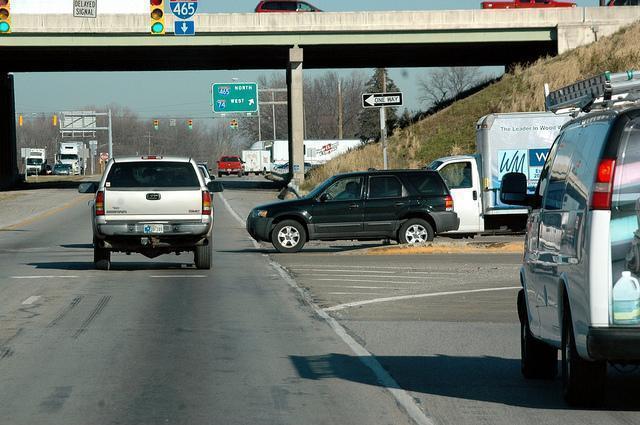How many traffic lights are hanging in the highway ahead facing toward the silver pickup truck?
Indicate the correct response by choosing from the four available options to answer the question.
Options: Seven, four, five, six. Five. 